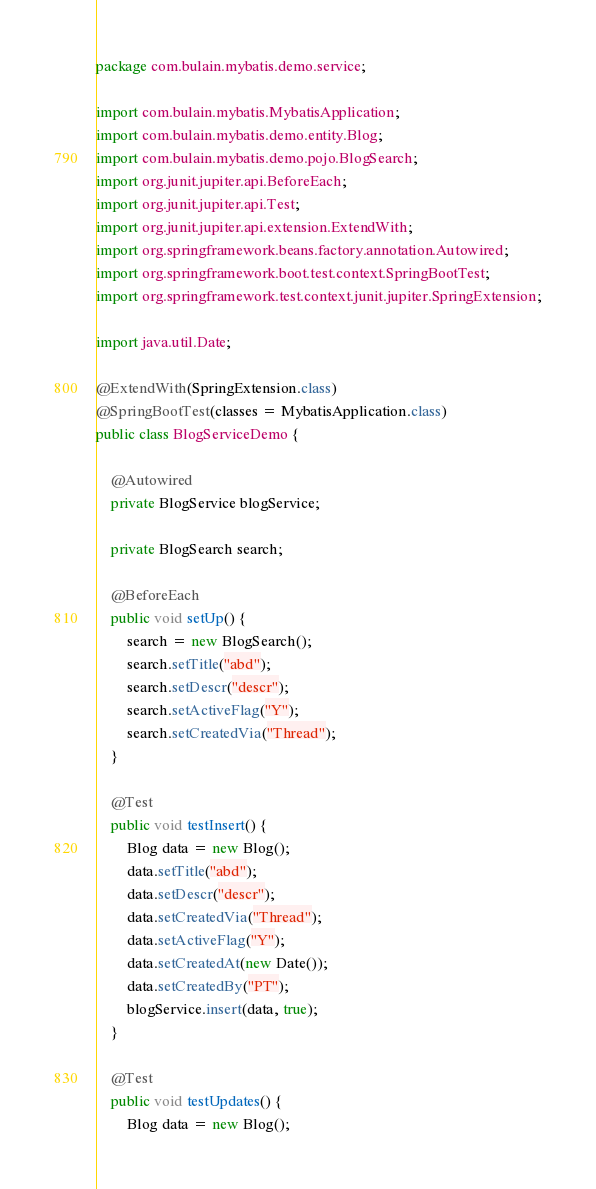<code> <loc_0><loc_0><loc_500><loc_500><_Java_>package com.bulain.mybatis.demo.service;

import com.bulain.mybatis.MybatisApplication;
import com.bulain.mybatis.demo.entity.Blog;
import com.bulain.mybatis.demo.pojo.BlogSearch;
import org.junit.jupiter.api.BeforeEach;
import org.junit.jupiter.api.Test;
import org.junit.jupiter.api.extension.ExtendWith;
import org.springframework.beans.factory.annotation.Autowired;
import org.springframework.boot.test.context.SpringBootTest;
import org.springframework.test.context.junit.jupiter.SpringExtension;

import java.util.Date;

@ExtendWith(SpringExtension.class)
@SpringBootTest(classes = MybatisApplication.class)
public class BlogServiceDemo {

	@Autowired
	private BlogService blogService;

	private BlogSearch search;

	@BeforeEach
	public void setUp() {
		search = new BlogSearch();
		search.setTitle("abd");
		search.setDescr("descr");
		search.setActiveFlag("Y");
		search.setCreatedVia("Thread");
	}

	@Test
	public void testInsert() {
		Blog data = new Blog();
		data.setTitle("abd");
		data.setDescr("descr");
		data.setCreatedVia("Thread");
		data.setActiveFlag("Y");
		data.setCreatedAt(new Date());
		data.setCreatedBy("PT");
		blogService.insert(data, true);
	}

	@Test
	public void testUpdates() {
		Blog data = new Blog();</code> 